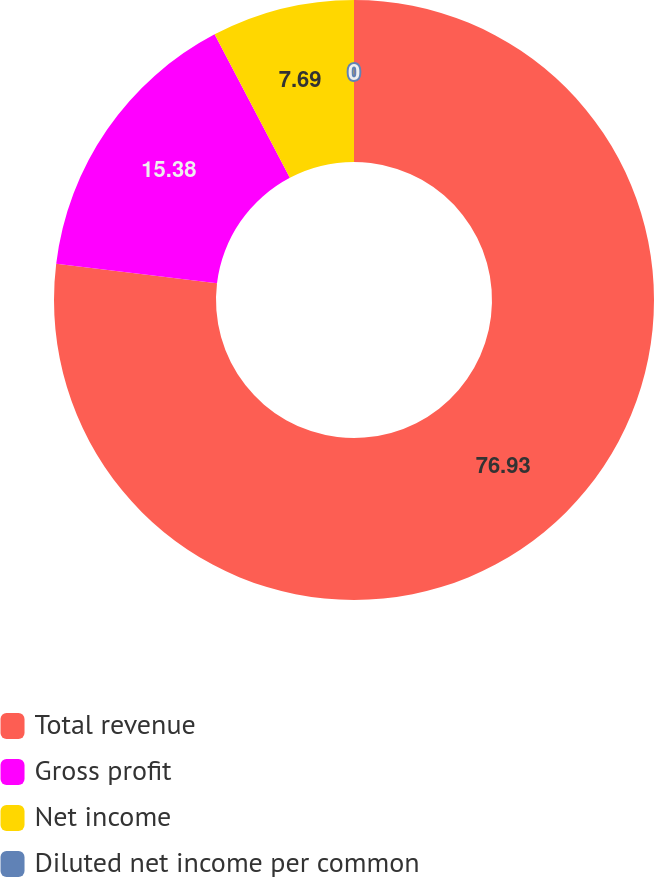Convert chart. <chart><loc_0><loc_0><loc_500><loc_500><pie_chart><fcel>Total revenue<fcel>Gross profit<fcel>Net income<fcel>Diluted net income per common<nl><fcel>76.92%<fcel>15.38%<fcel>7.69%<fcel>0.0%<nl></chart> 